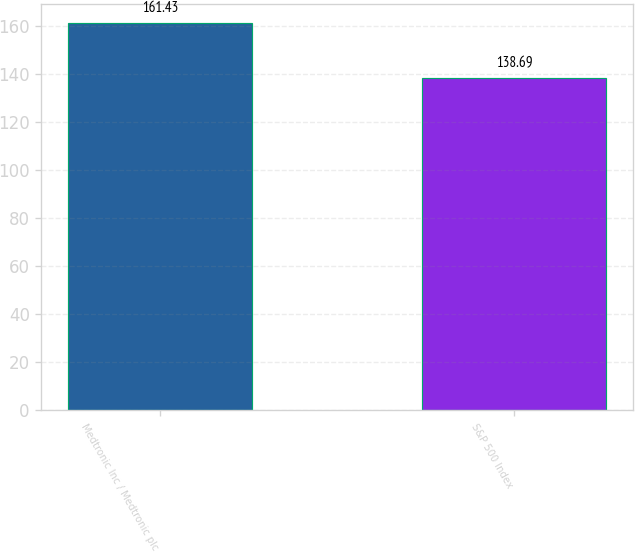Convert chart to OTSL. <chart><loc_0><loc_0><loc_500><loc_500><bar_chart><fcel>Medtronic Inc / Medtronic plc<fcel>S&P 500 Index<nl><fcel>161.43<fcel>138.69<nl></chart> 